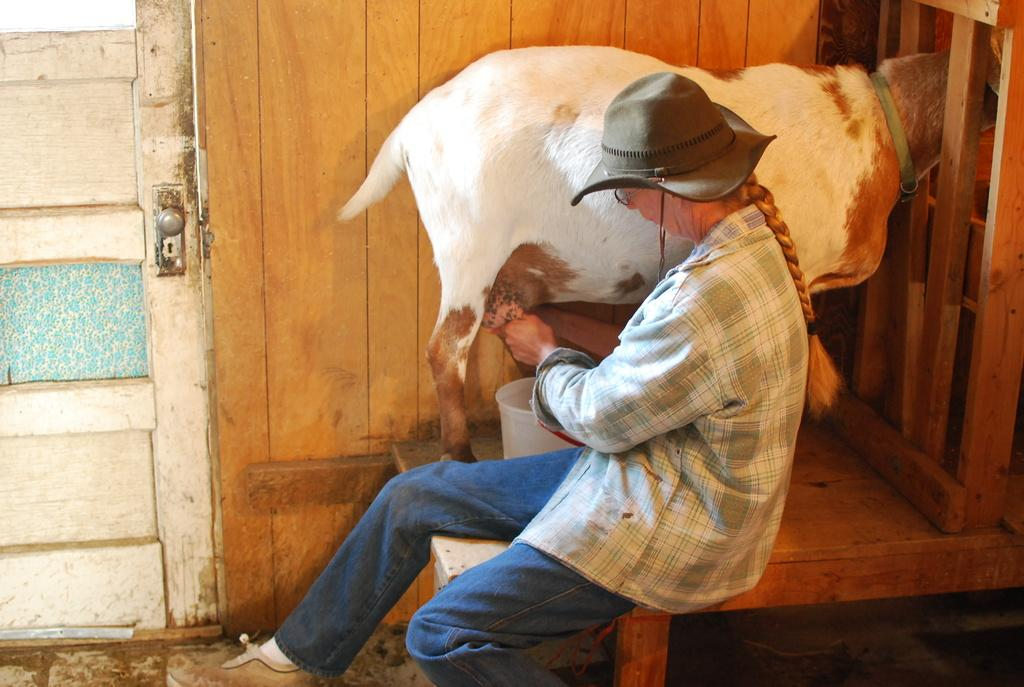Who is present in the image? There is a man in the image. What animal is in front of the man? There is a goat in front of the man. What object can be seen in the image? There is a bucket in the image. What architectural feature is visible in the image? There is a door in the image. What type of polish is being applied to the church in the image? There is no church present in the image, nor is any polish being applied. 